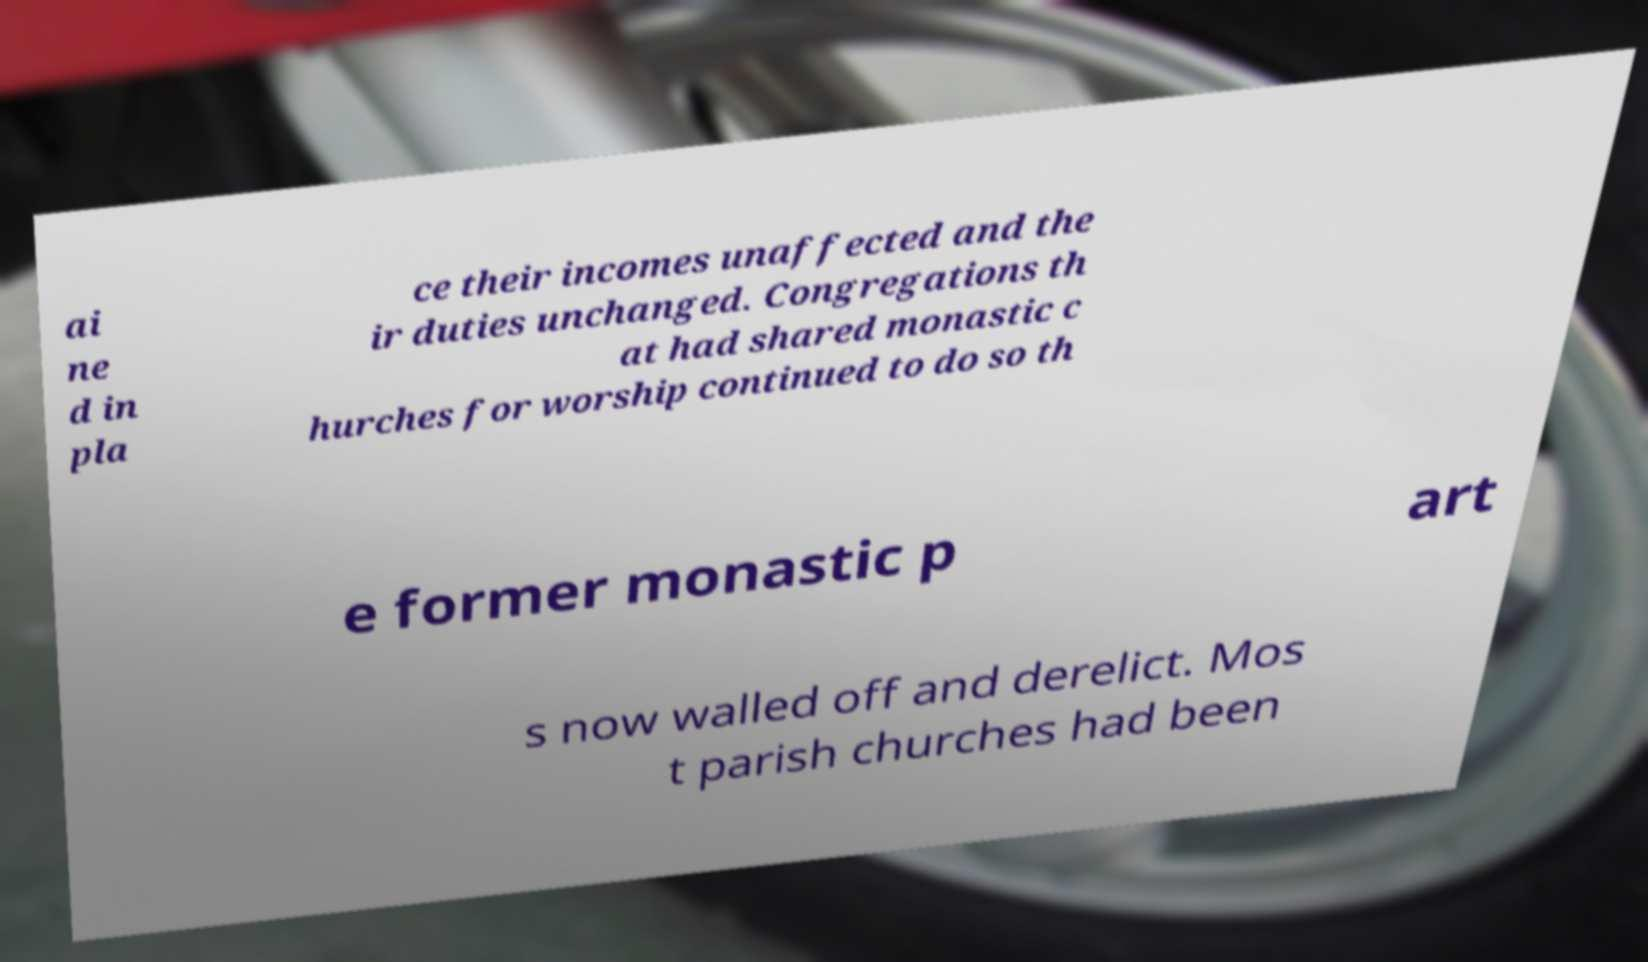Could you assist in decoding the text presented in this image and type it out clearly? ai ne d in pla ce their incomes unaffected and the ir duties unchanged. Congregations th at had shared monastic c hurches for worship continued to do so th e former monastic p art s now walled off and derelict. Mos t parish churches had been 